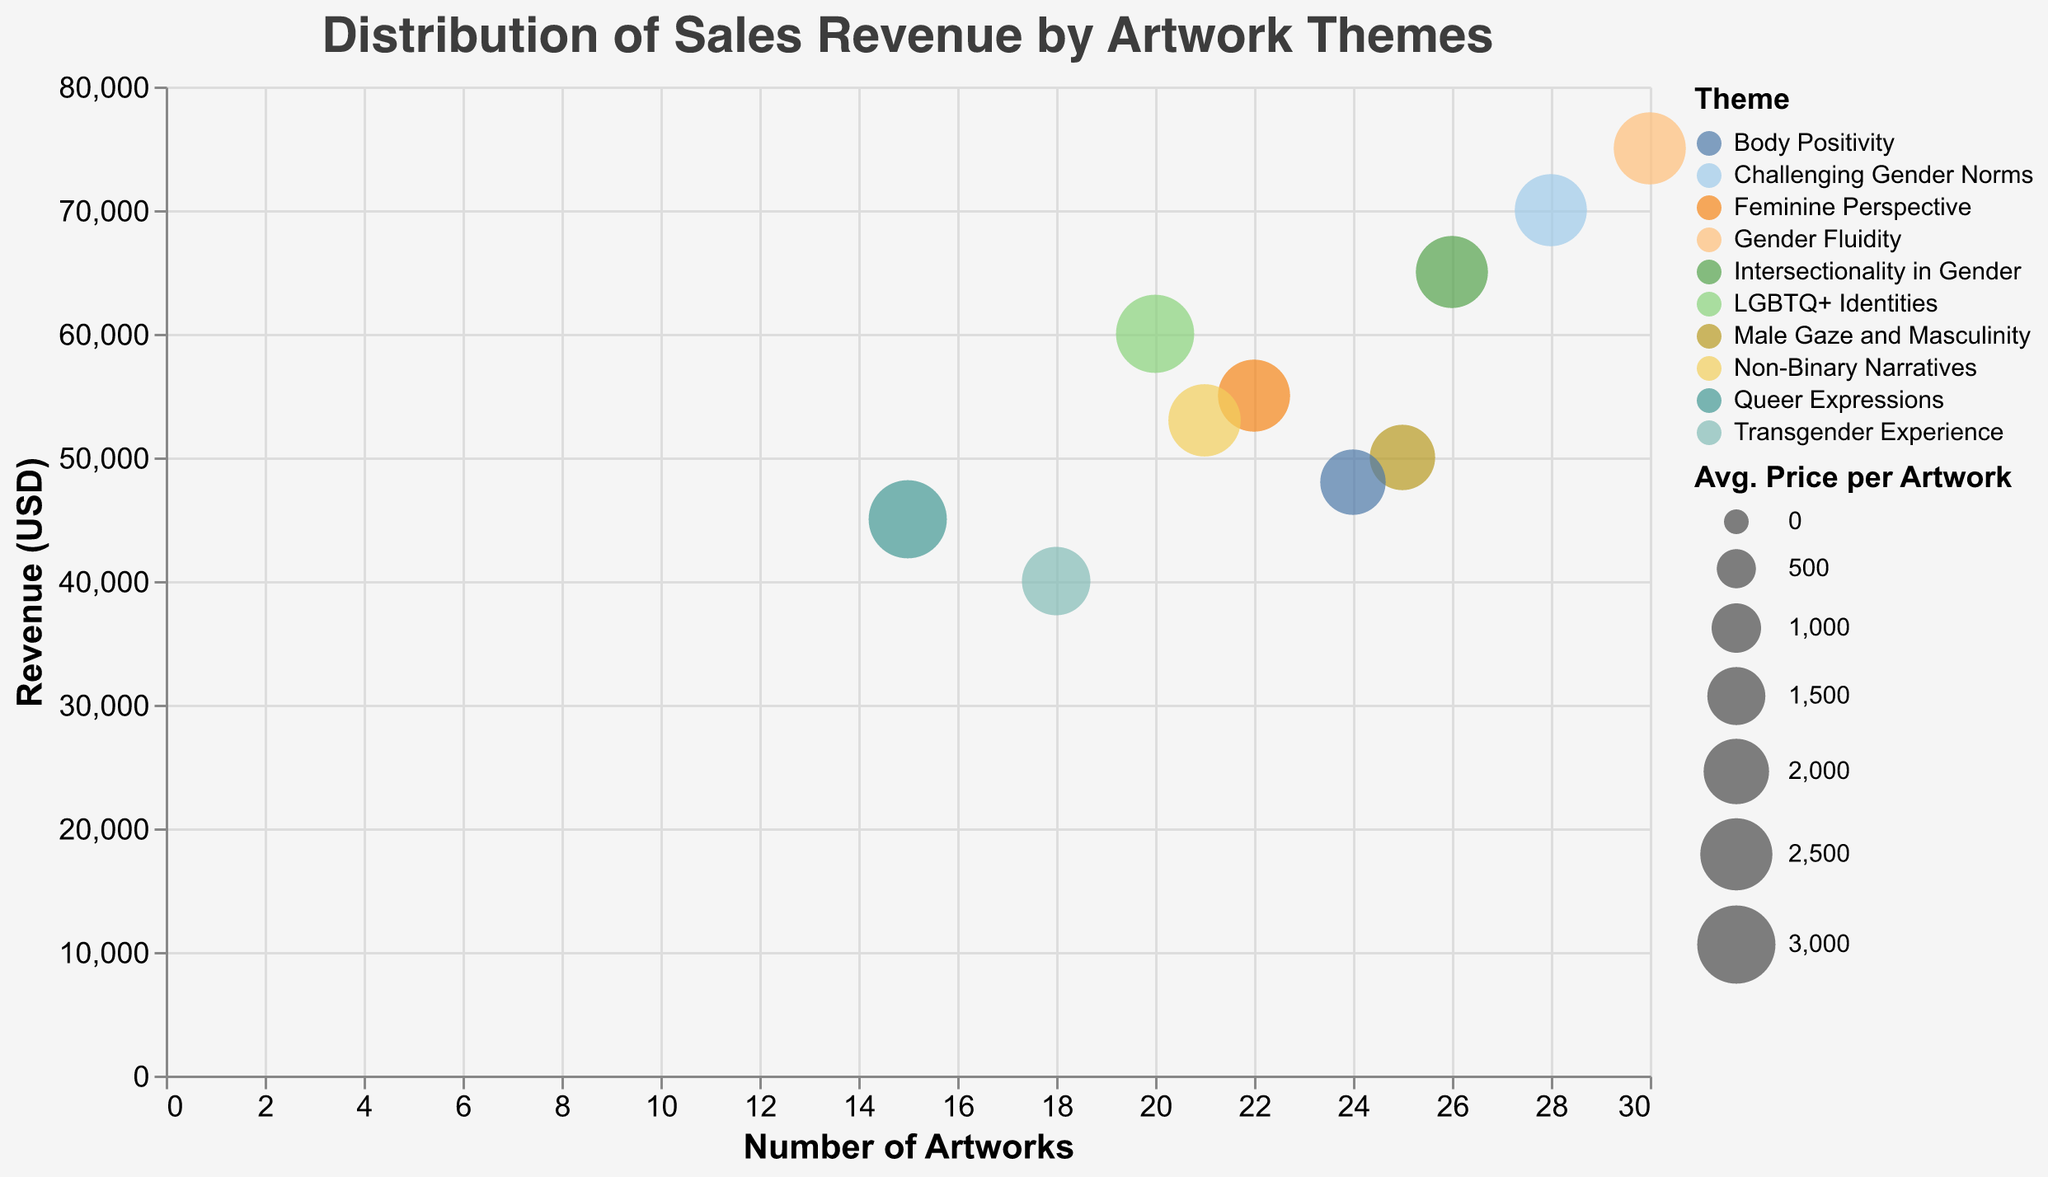What's the highest revenue generated by an artwork theme? The highest revenue is indicated by the highest point on the y-axis, which is $75,000 for the theme "Gender Fluidity".
Answer: $75,000 Which theme has the highest average price per artwork? The size of the bubbles represents the average price per artwork. The largest bubble corresponds to the theme "LGBTQ+ Identities" and "Queer Expressions", both with an average price of $3,000.
Answer: LGBTQ+ Identities, Queer Expressions How many artworks are associated with the theme generating $40,000 in revenue? Find the bubble at $40,000 on the y-axis and check its position on the x-axis, which is 18 artworks.
Answer: 18 artworks Which theme has the lowest number of artworks? The theme with the smallest number on the x-axis is "Queer Expressions" with 15 artworks.
Answer: Queer Expressions What is the revenue range of the themes displaying between 20 and 30 artworks? Identify the bubbles between 20 and 30 on the x-axis and check their corresponding y-axis values. Themes are:
- "LGBTQ+ Identities" - $60,000
- "Non-Binary Narratives" - $53,000
- "Feminine Perspective" - £55,000
- "Male Gaze and Masculinity" - $50,000
- "Intersectionality in Gender" - $65,000
- "Challenging Gender Norms" - $70,000
- "Body Positivity" - $48,000
- "Gender Fluidity" - $75,000
Revenue range is $48,000 to $75,000.
Answer: $48,000 to $75,000 Between "Intersectionality in Gender" and "Challenging Gender Norms", which theme generated a higher revenue? Compare their positions on the y-axis. "Challenging Gender Norms" generated $70,000 while "Intersectionality in Gender" generated $65,000. "Challenging Gender Norms" has higher revenue.
Answer: Challenging Gender Norms Which theme has the highest revenue but doesn't have the highest average price per artwork? "Gender Fluidity" has the highest revenue at $75,000, but its average price per artwork is not the highest at $2,500.
Answer: Gender Fluidity What's the combined number of artworks for "Transgender Experience" and "Body Positivity"? The number of artworks for "Transgender Experience" is 18, and for "Body Positivity" it is 24. Sum them up: 
18 + 24 = 42
Answer: 42 If you were to collect artworks based solely on revenue, which two themes would you primarily focus on? Identify the two highest points on the y-axis, which are "Gender Fluidity" at $75,000 and "Challenging Gender Norms" at $70,000.
Answer: Gender Fluidity, Challenging Gender Norms 